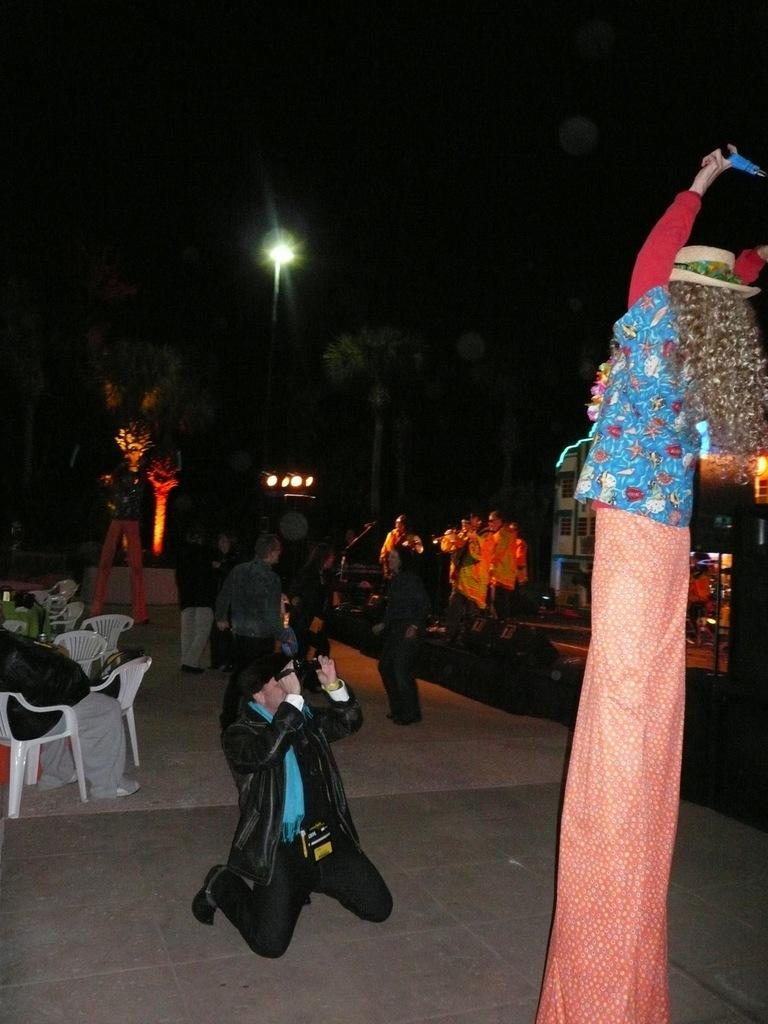Who is present in the image? There is a man in the image. What is the man holding in the image? The man is holding a camera. What type of furniture can be seen in the image? There are chairs in the image. What is happening on the road in the image? There are people standing on the road. What type of plant is visible in the image? There is a tree in the image. What can be used to provide illumination in the image? There is a light in the image. How many sheep are visible in the image? There are no sheep present in the image. What type of weather condition is depicted in the image? The provided facts do not mention any weather conditions, so it cannot be determined from the image. 